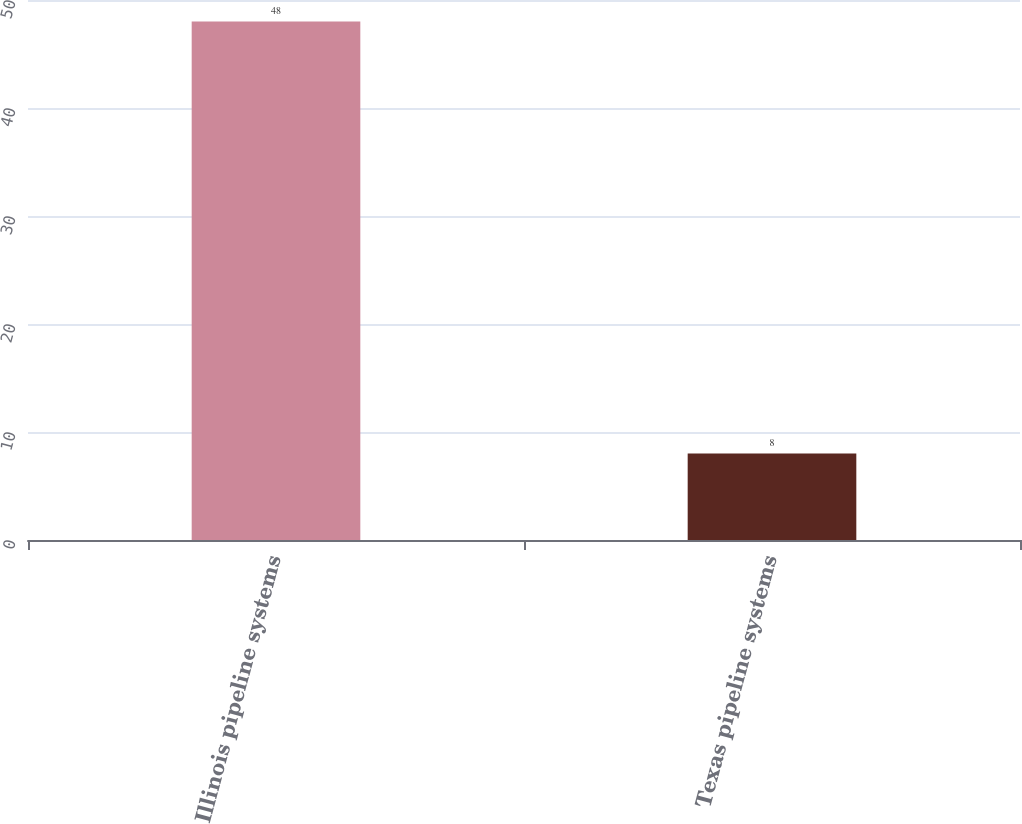<chart> <loc_0><loc_0><loc_500><loc_500><bar_chart><fcel>Illinois pipeline systems<fcel>Texas pipeline systems<nl><fcel>48<fcel>8<nl></chart> 